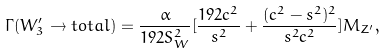<formula> <loc_0><loc_0><loc_500><loc_500>\Gamma ( W _ { 3 } ^ { \prime } \rightarrow t o t a l ) = \frac { \alpha } { 1 9 2 S _ { W } ^ { 2 } } [ \frac { 1 9 2 c ^ { 2 } } { s ^ { 2 } } + \frac { ( c ^ { 2 } - s ^ { 2 } ) ^ { 2 } } { s ^ { 2 } c ^ { 2 } } ] M _ { Z ^ { \prime } } ,</formula> 